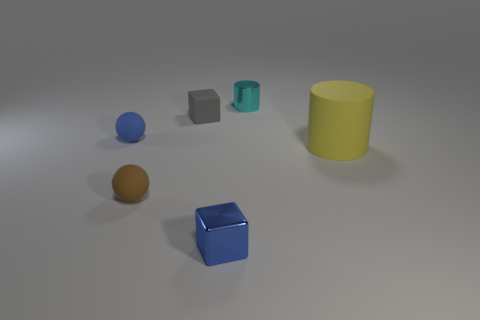Subtract all cubes. How many objects are left? 4 Add 3 purple matte balls. How many objects exist? 9 Add 1 large rubber cylinders. How many large rubber cylinders exist? 2 Subtract 0 yellow balls. How many objects are left? 6 Subtract all yellow matte things. Subtract all small gray matte objects. How many objects are left? 4 Add 3 brown objects. How many brown objects are left? 4 